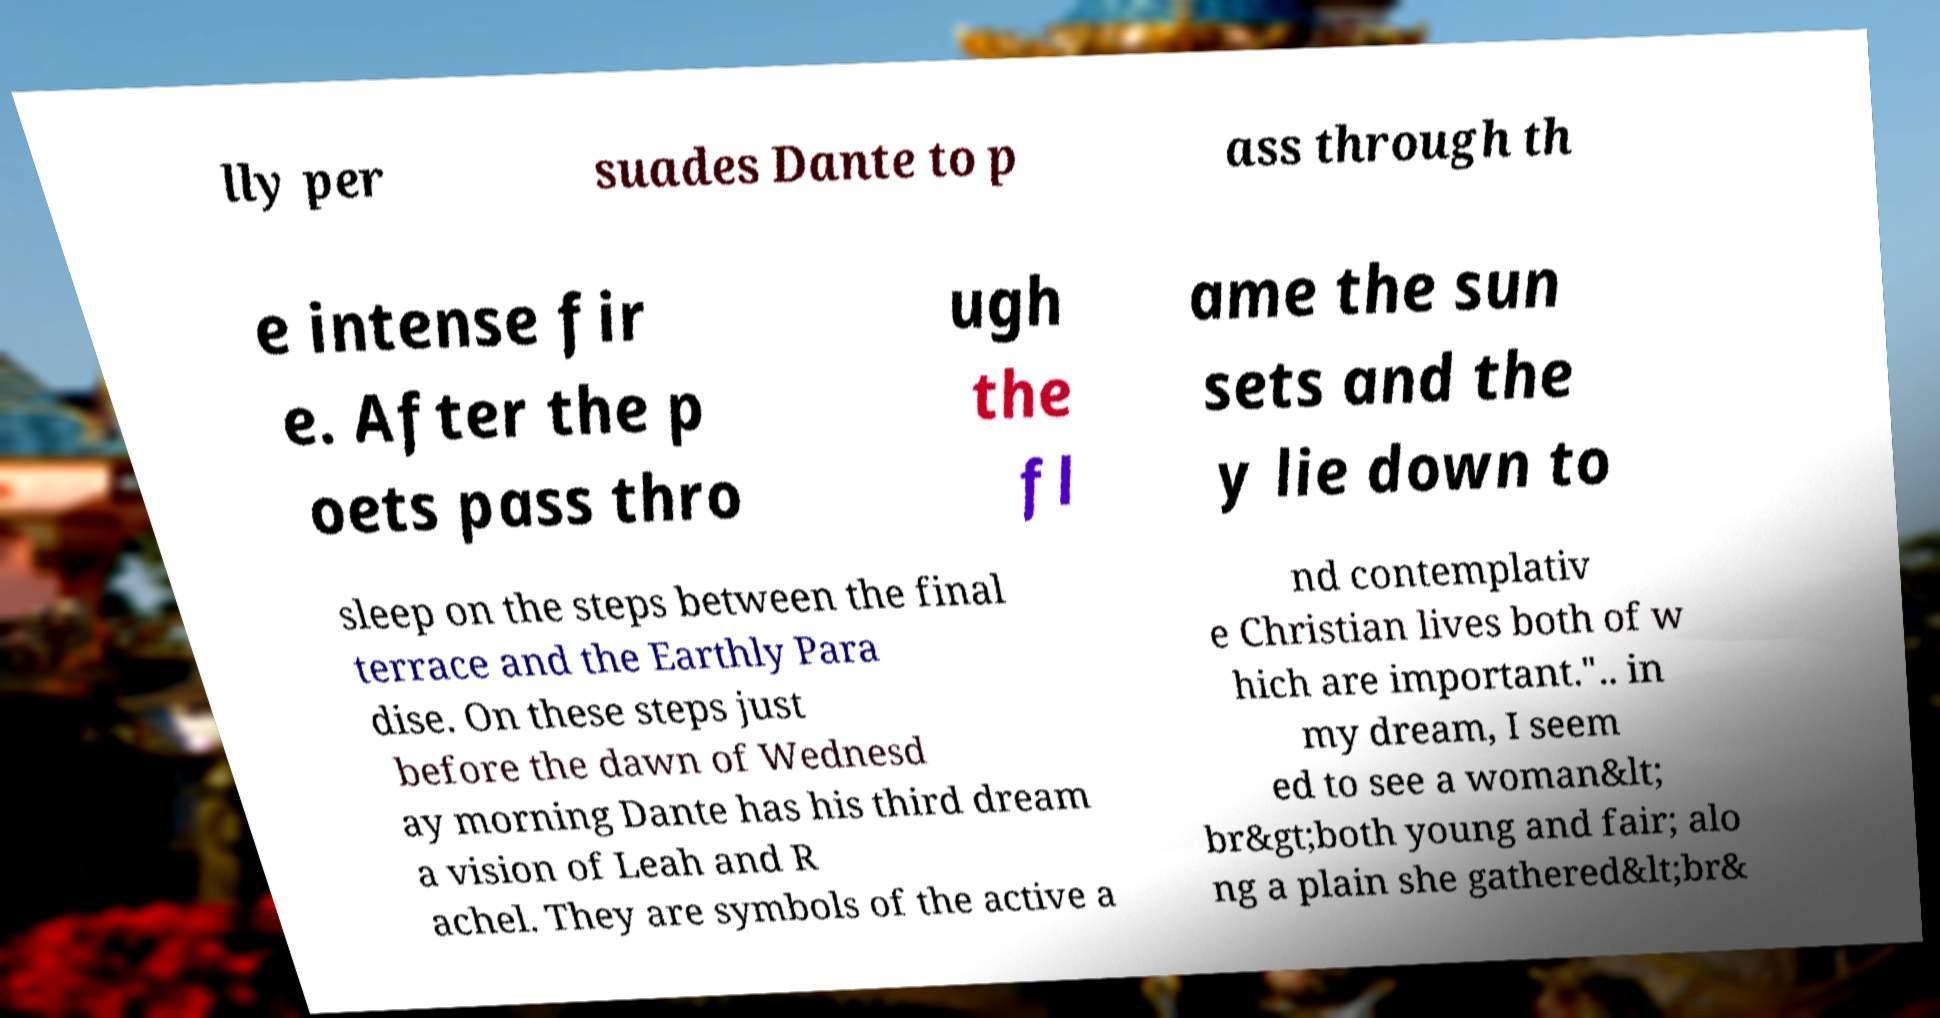For documentation purposes, I need the text within this image transcribed. Could you provide that? lly per suades Dante to p ass through th e intense fir e. After the p oets pass thro ugh the fl ame the sun sets and the y lie down to sleep on the steps between the final terrace and the Earthly Para dise. On these steps just before the dawn of Wednesd ay morning Dante has his third dream a vision of Leah and R achel. They are symbols of the active a nd contemplativ e Christian lives both of w hich are important.".. in my dream, I seem ed to see a woman&lt; br&gt;both young and fair; alo ng a plain she gathered&lt;br& 